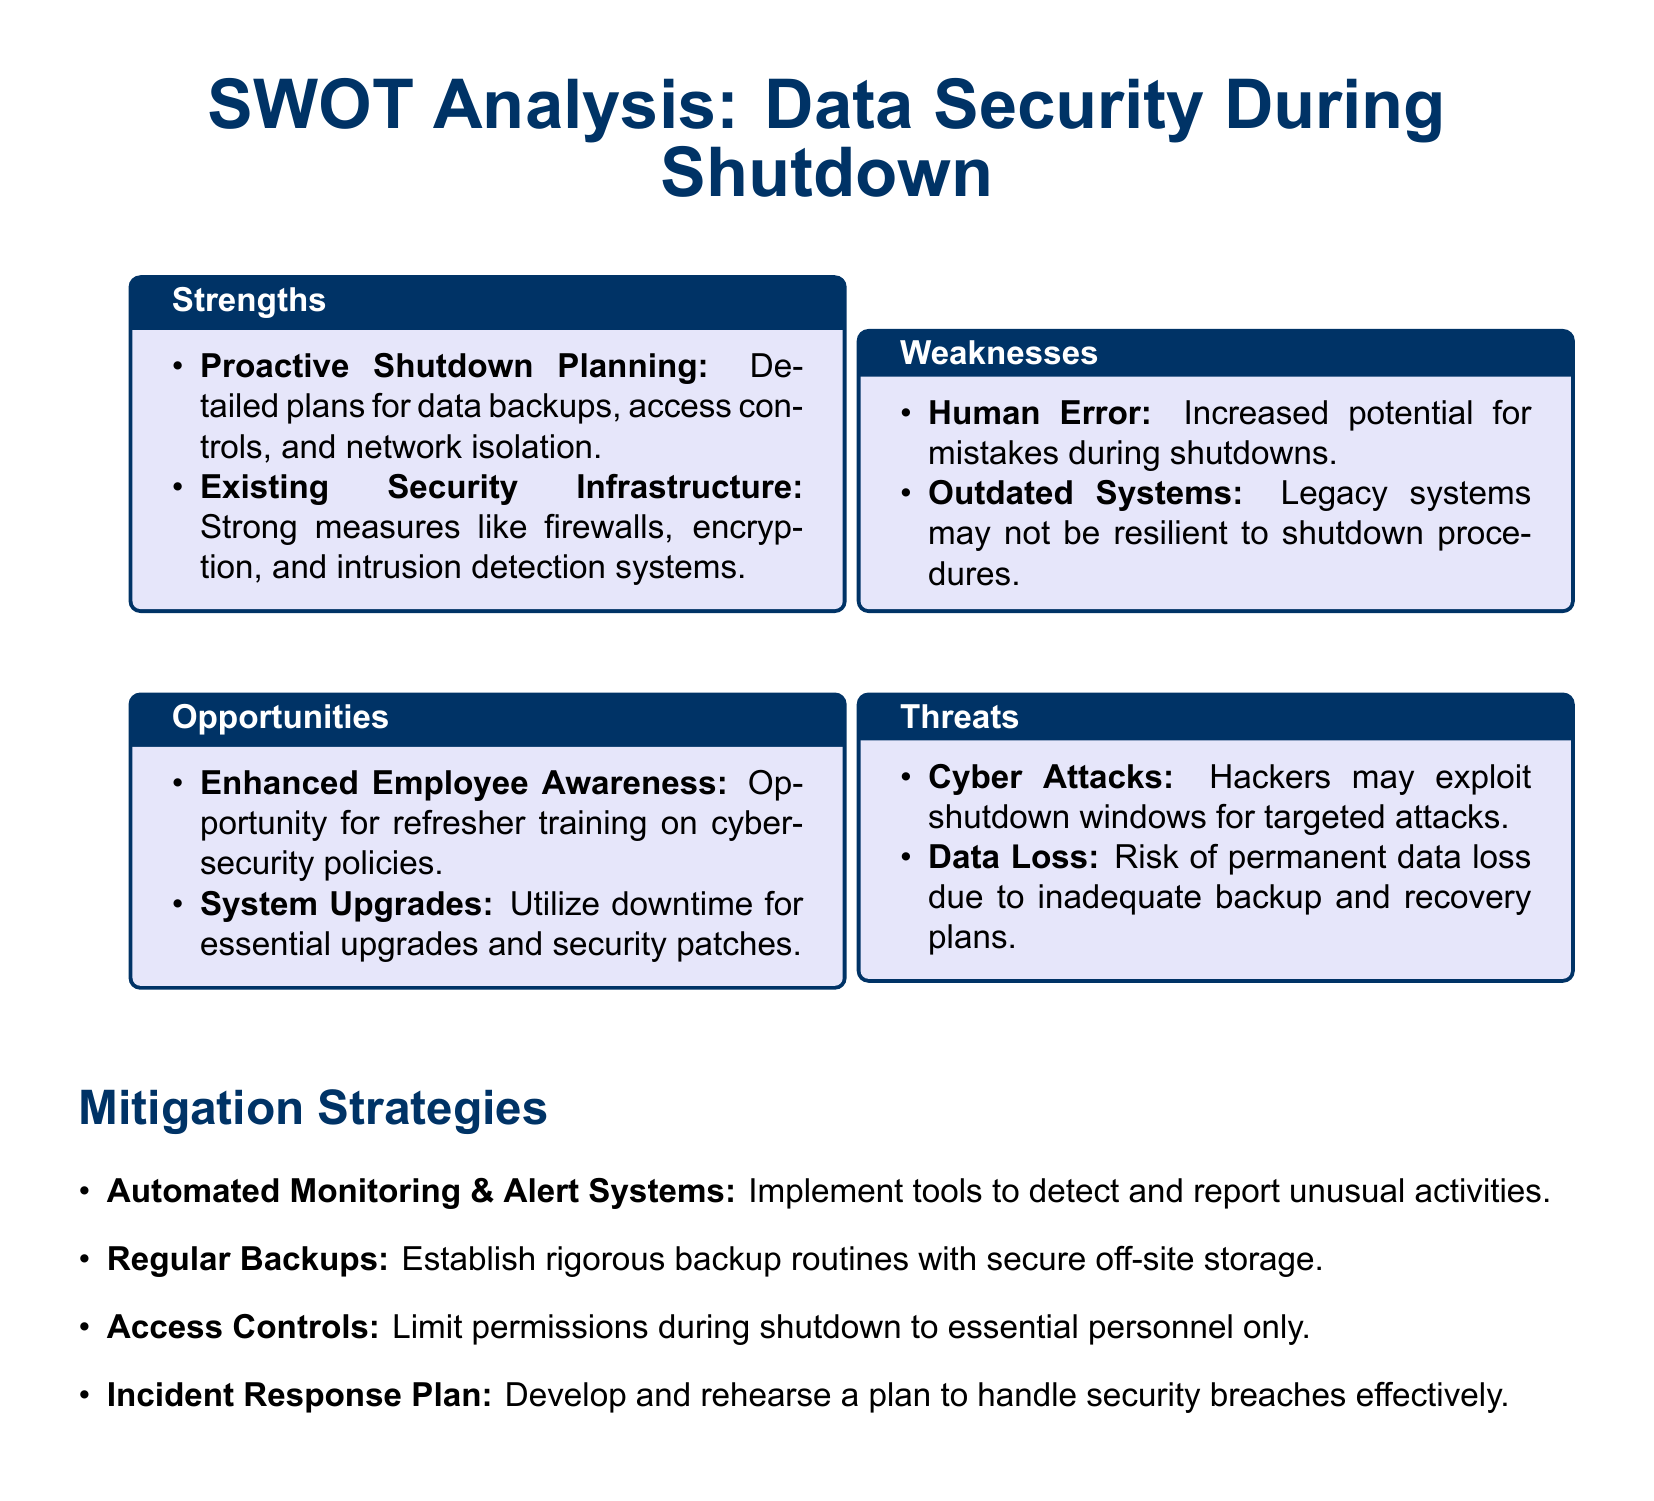What are the strengths identified? The strengths are highlighted in the SWOT analysis section entitled "Strengths."
Answer: Proactive Shutdown Planning, Existing Security Infrastructure What is a weakness related to human factors? The document lists weaknesses under the "Weaknesses" section, specifically addressing human factors.
Answer: Human Error What opportunity exists for employee training? The opportunities section mentions a specific chance for training, focusing on cybersecurity policies.
Answer: Enhanced Employee Awareness What is a significant threat mentioned regarding cyber activities? The threats section discusses a major concern about external attacks during a shutdown.
Answer: Cyber Attacks What mitigation strategy involves personnel access? The mitigation strategies outline a specific approach related to access during the shutdown.
Answer: Access Controls How many strengths are listed in total? Counting the items in the "Strengths" section provides the total number of strengths.
Answer: 2 Which infrastructure is described as being strong? The document provides details about existing security measures that protect data.
Answer: Security Infrastructure What does the document suggest for backup routines? The mitigation strategies section outlines recommendations for maintaining backup routines.
Answer: Regular Backups What incident is planned for with a response plan? The mitigation strategies specify planning for a particular type of security concern.
Answer: Security breaches 